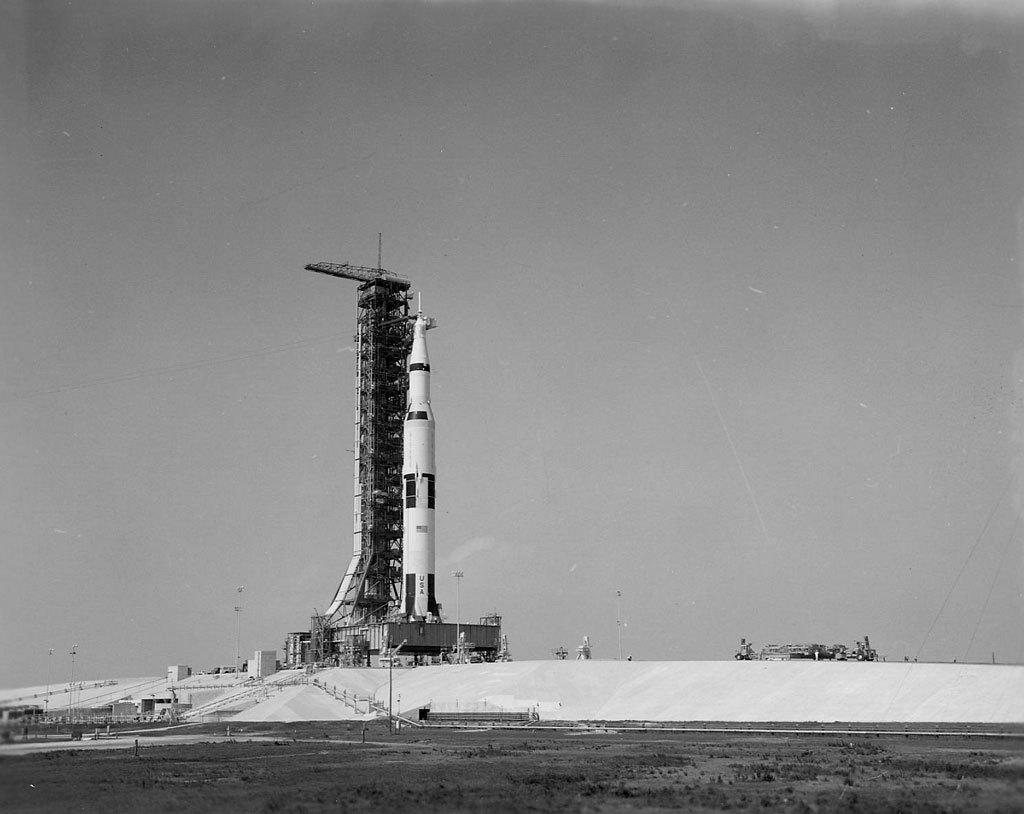What is the main subject of the picture? The main subject of the picture is a rocket. Can you describe any other objects in the picture? There are some objects in the picture, but their specific details are not mentioned in the facts. What can be seen in the background of the image? The sky is visible in the background of the image. What type of advertisement can be seen on the rocket in the image? There is no advertisement present on the rocket in the image. How many rabbits are visible in the image? There are no rabbits present in the image. 